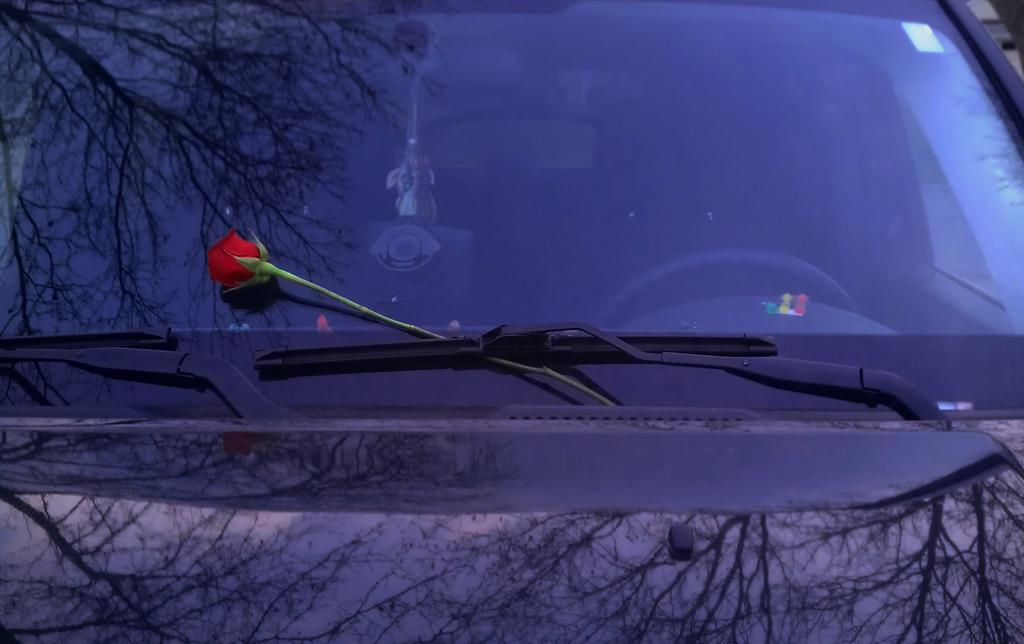What is placed on the windshield in the image? There is a flower on the windshield screen. What is used to clean the windshield? Glass wipers are present on the windshield. What can be seen through the windshield glass? The steering and a toy are visible through the windshield glass. What is the reflection of in the vehicle? The reflection of trees is visible on the vehicle. How many cows are grazing in the background of the image? There are no cows present in the image; it features a vehicle with a flower on the windshield, glass wipers, a toy, and the reflection of trees. What type of geese are flying over the vehicle in the image? There are no geese present in the image; it features a vehicle with a flower on the windshield, glass wipers, a toy, and the reflection of trees. 